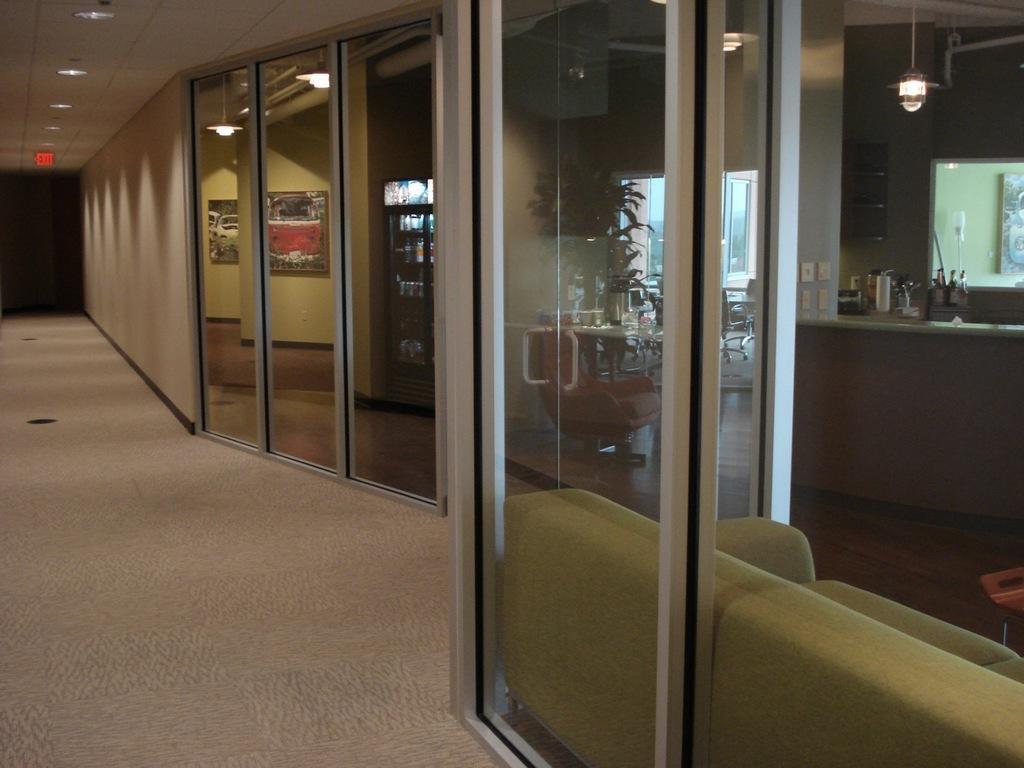Please provide a concise description of this image. On the left side we can see the floor and we can see wall, glass doors and lights, an object on the ceiling. On the glass doors we can see the reflections of plants, objects, lights and frames on the wall. 